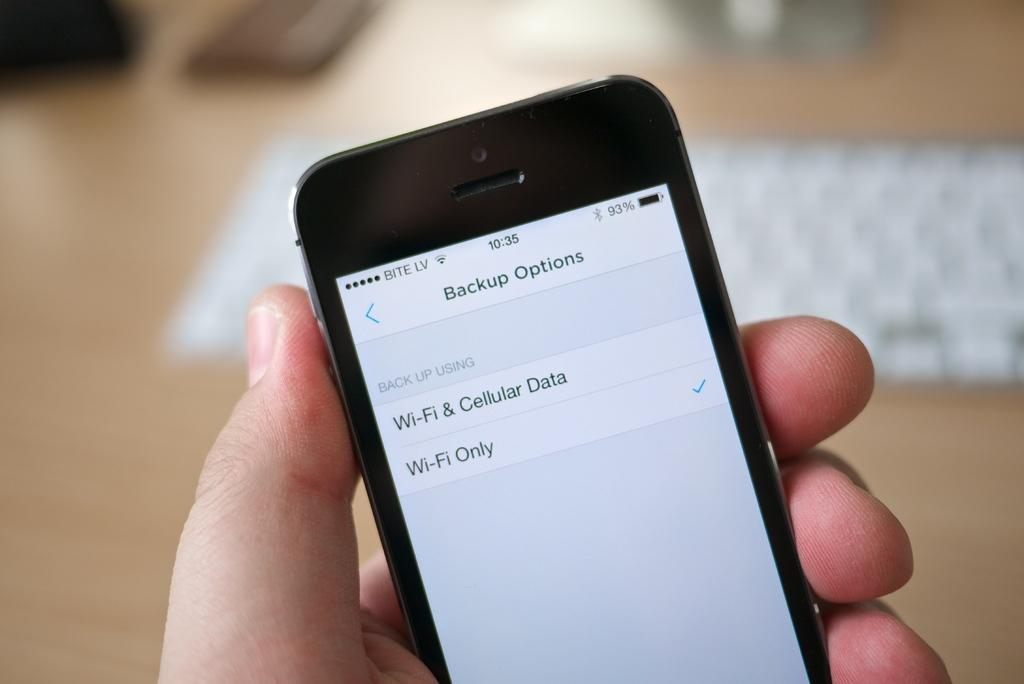<image>
Write a terse but informative summary of the picture. a cell phone screen showing words Back up Options 